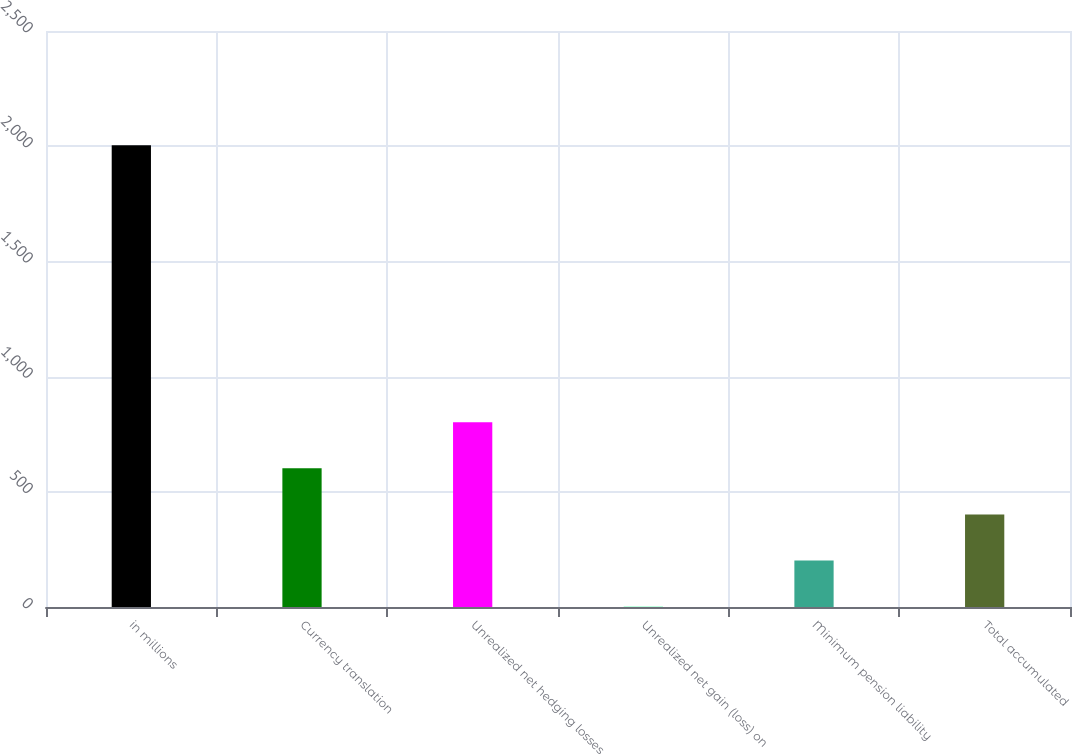Convert chart to OTSL. <chart><loc_0><loc_0><loc_500><loc_500><bar_chart><fcel>in millions<fcel>Currency translation<fcel>Unrealized net hedging losses<fcel>Unrealized net gain (loss) on<fcel>Minimum pension liability<fcel>Total accumulated<nl><fcel>2004<fcel>601.9<fcel>802.2<fcel>1<fcel>201.3<fcel>401.6<nl></chart> 